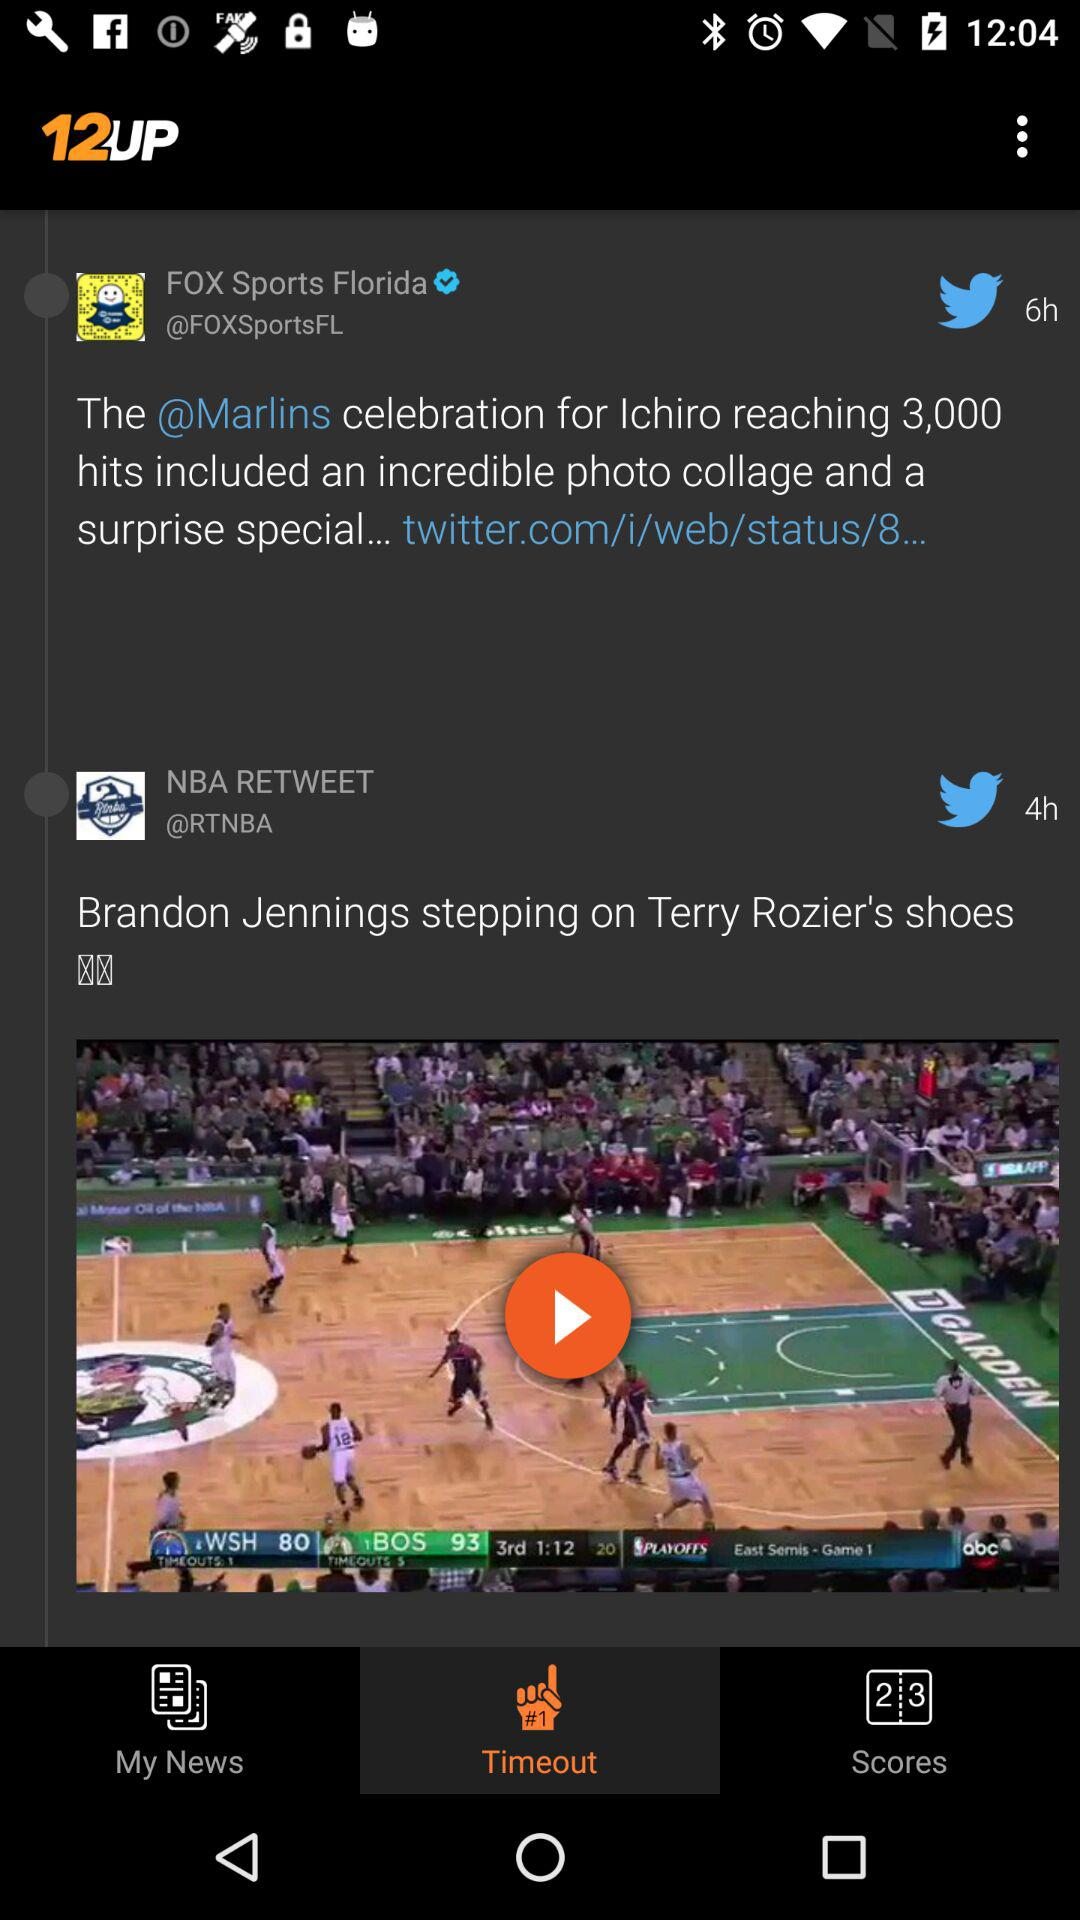What is the name of the application? The name of the application is "12UP". 